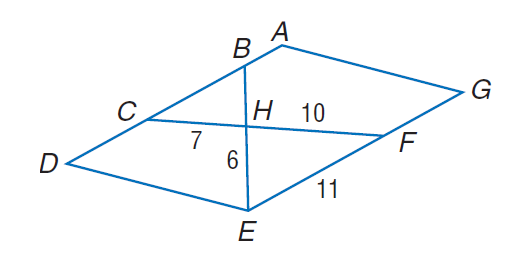Question: Find the perimeter of \triangle C B H, if \triangle C B H \sim \triangle F E H, A D E G is a parallelogram, C H = 7, F H = 10, F E = 11, and E H = 6.
Choices:
A. 18.9
B. 23.1
C. 31.5
D. 38.6
Answer with the letter. Answer: A 